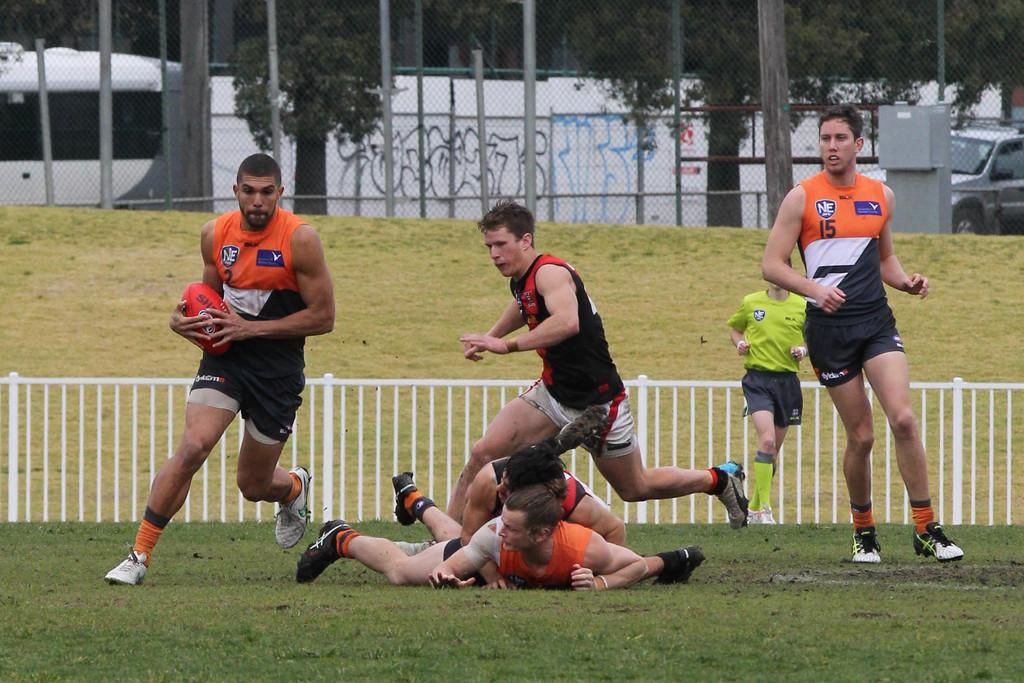<image>
Share a concise interpretation of the image provided. The man in the number 2 jersey runs across the field with a rugby ball. 